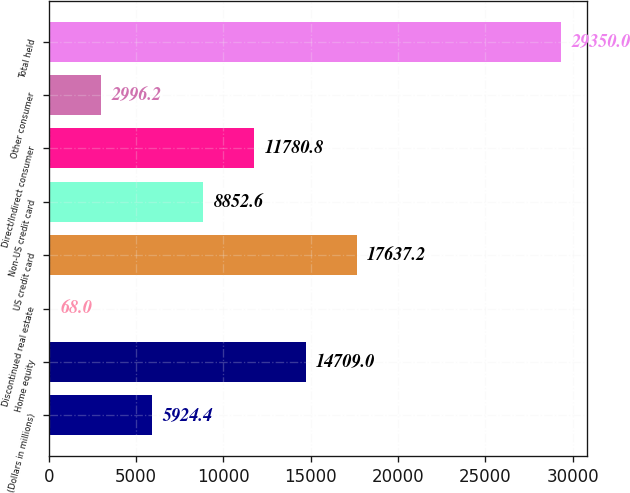<chart> <loc_0><loc_0><loc_500><loc_500><bar_chart><fcel>(Dollars in millions)<fcel>Home equity<fcel>Discontinued real estate<fcel>US credit card<fcel>Non-US credit card<fcel>Direct/Indirect consumer<fcel>Other consumer<fcel>Total held<nl><fcel>5924.4<fcel>14709<fcel>68<fcel>17637.2<fcel>8852.6<fcel>11780.8<fcel>2996.2<fcel>29350<nl></chart> 